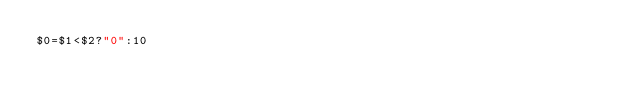Convert code to text. <code><loc_0><loc_0><loc_500><loc_500><_Awk_>$0=$1<$2?"0":10</code> 